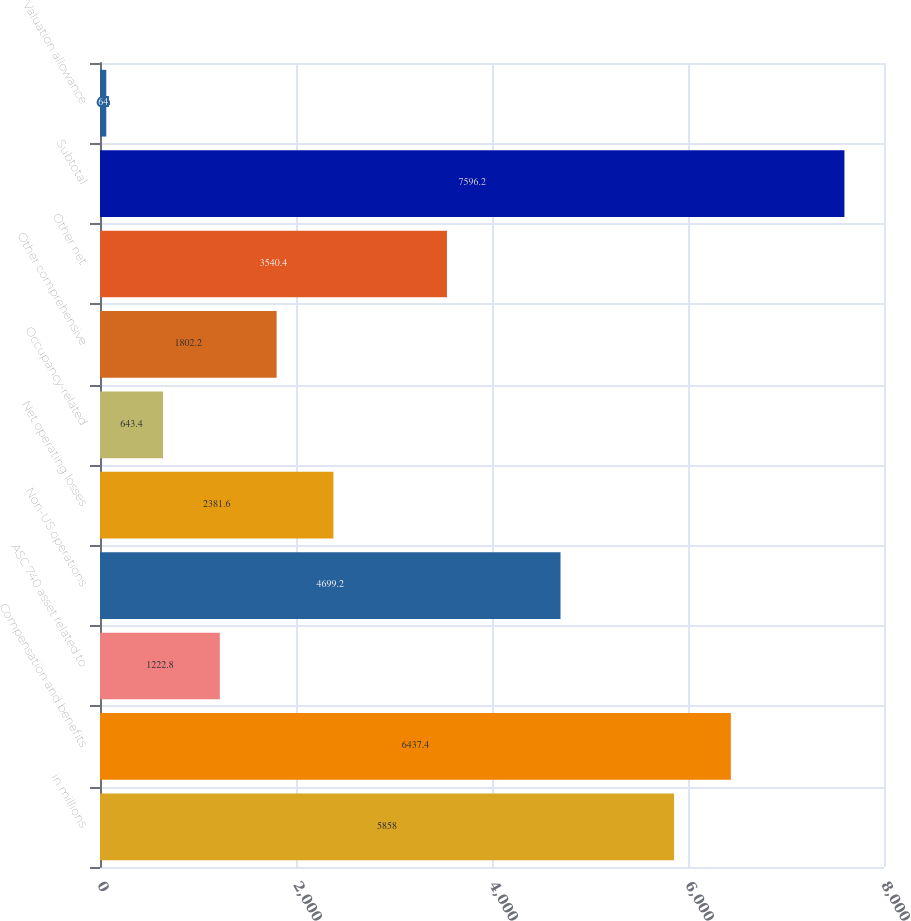<chart> <loc_0><loc_0><loc_500><loc_500><bar_chart><fcel>in millions<fcel>Compensation and benefits<fcel>ASC 740 asset related to<fcel>Non-US operations<fcel>Net operating losses<fcel>Occupancy-related<fcel>Other comprehensive<fcel>Other net<fcel>Subtotal<fcel>Valuation allowance<nl><fcel>5858<fcel>6437.4<fcel>1222.8<fcel>4699.2<fcel>2381.6<fcel>643.4<fcel>1802.2<fcel>3540.4<fcel>7596.2<fcel>64<nl></chart> 